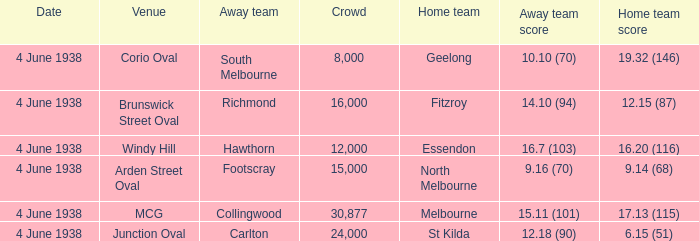What was the score for Geelong? 10.10 (70). 